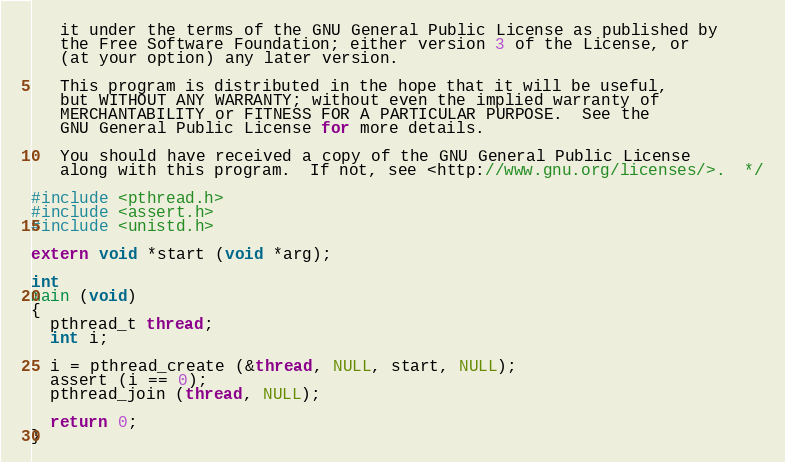<code> <loc_0><loc_0><loc_500><loc_500><_C_>   it under the terms of the GNU General Public License as published by
   the Free Software Foundation; either version 3 of the License, or
   (at your option) any later version.

   This program is distributed in the hope that it will be useful,
   but WITHOUT ANY WARRANTY; without even the implied warranty of
   MERCHANTABILITY or FITNESS FOR A PARTICULAR PURPOSE.  See the
   GNU General Public License for more details.

   You should have received a copy of the GNU General Public License
   along with this program.  If not, see <http://www.gnu.org/licenses/>.  */

#include <pthread.h>
#include <assert.h>
#include <unistd.h>

extern void *start (void *arg);

int
main (void)
{
  pthread_t thread;
  int i;

  i = pthread_create (&thread, NULL, start, NULL);
  assert (i == 0);
  pthread_join (thread, NULL);

  return 0;
}
</code> 